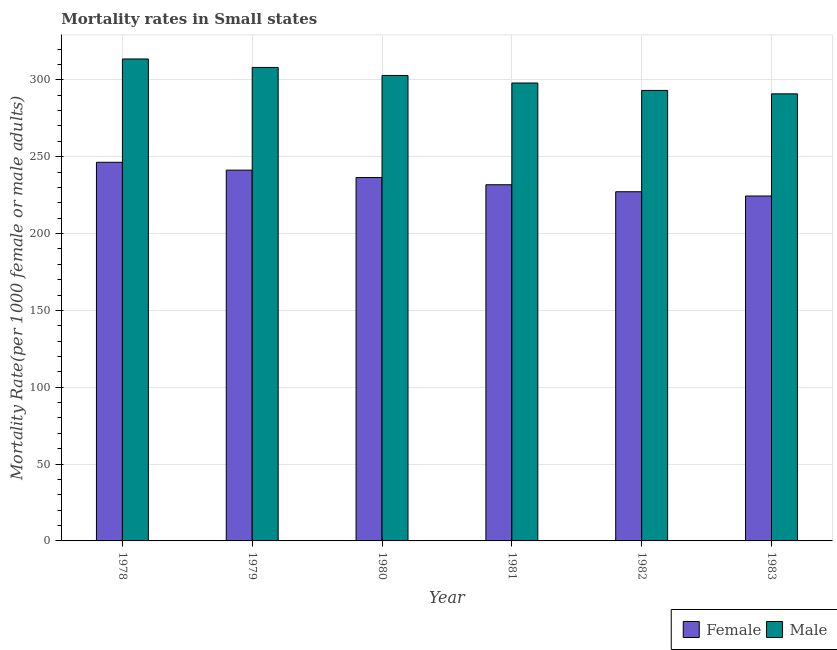How many different coloured bars are there?
Give a very brief answer. 2. How many groups of bars are there?
Your response must be concise. 6. Are the number of bars on each tick of the X-axis equal?
Provide a succinct answer. Yes. How many bars are there on the 5th tick from the right?
Ensure brevity in your answer.  2. What is the male mortality rate in 1982?
Your answer should be very brief. 293.12. Across all years, what is the maximum female mortality rate?
Your answer should be compact. 246.35. Across all years, what is the minimum female mortality rate?
Give a very brief answer. 224.41. In which year was the male mortality rate maximum?
Keep it short and to the point. 1978. What is the total female mortality rate in the graph?
Ensure brevity in your answer.  1407.39. What is the difference between the female mortality rate in 1978 and that in 1981?
Provide a short and direct response. 14.61. What is the difference between the male mortality rate in 1978 and the female mortality rate in 1983?
Ensure brevity in your answer.  22.68. What is the average male mortality rate per year?
Provide a short and direct response. 301.08. In the year 1981, what is the difference between the male mortality rate and female mortality rate?
Provide a succinct answer. 0. In how many years, is the male mortality rate greater than 150?
Your response must be concise. 6. What is the ratio of the female mortality rate in 1980 to that in 1983?
Keep it short and to the point. 1.05. Is the female mortality rate in 1978 less than that in 1981?
Offer a terse response. No. What is the difference between the highest and the second highest female mortality rate?
Make the answer very short. 5.1. What is the difference between the highest and the lowest female mortality rate?
Your response must be concise. 21.94. Is the sum of the male mortality rate in 1981 and 1983 greater than the maximum female mortality rate across all years?
Your response must be concise. Yes. Are all the bars in the graph horizontal?
Provide a short and direct response. No. What is the difference between two consecutive major ticks on the Y-axis?
Ensure brevity in your answer.  50. Are the values on the major ticks of Y-axis written in scientific E-notation?
Ensure brevity in your answer.  No. Where does the legend appear in the graph?
Offer a very short reply. Bottom right. How many legend labels are there?
Your answer should be very brief. 2. How are the legend labels stacked?
Make the answer very short. Horizontal. What is the title of the graph?
Keep it short and to the point. Mortality rates in Small states. Does "Money lenders" appear as one of the legend labels in the graph?
Your response must be concise. No. What is the label or title of the X-axis?
Provide a short and direct response. Year. What is the label or title of the Y-axis?
Provide a succinct answer. Mortality Rate(per 1000 female or male adults). What is the Mortality Rate(per 1000 female or male adults) in Female in 1978?
Ensure brevity in your answer.  246.35. What is the Mortality Rate(per 1000 female or male adults) of Male in 1978?
Offer a terse response. 313.58. What is the Mortality Rate(per 1000 female or male adults) of Female in 1979?
Give a very brief answer. 241.25. What is the Mortality Rate(per 1000 female or male adults) in Male in 1979?
Provide a short and direct response. 308.07. What is the Mortality Rate(per 1000 female or male adults) of Female in 1980?
Give a very brief answer. 236.45. What is the Mortality Rate(per 1000 female or male adults) in Male in 1980?
Give a very brief answer. 302.86. What is the Mortality Rate(per 1000 female or male adults) of Female in 1981?
Offer a terse response. 231.74. What is the Mortality Rate(per 1000 female or male adults) in Male in 1981?
Ensure brevity in your answer.  297.94. What is the Mortality Rate(per 1000 female or male adults) in Female in 1982?
Give a very brief answer. 227.19. What is the Mortality Rate(per 1000 female or male adults) in Male in 1982?
Keep it short and to the point. 293.12. What is the Mortality Rate(per 1000 female or male adults) in Female in 1983?
Make the answer very short. 224.41. What is the Mortality Rate(per 1000 female or male adults) in Male in 1983?
Ensure brevity in your answer.  290.89. Across all years, what is the maximum Mortality Rate(per 1000 female or male adults) of Female?
Provide a short and direct response. 246.35. Across all years, what is the maximum Mortality Rate(per 1000 female or male adults) in Male?
Your response must be concise. 313.58. Across all years, what is the minimum Mortality Rate(per 1000 female or male adults) of Female?
Your answer should be compact. 224.41. Across all years, what is the minimum Mortality Rate(per 1000 female or male adults) in Male?
Offer a terse response. 290.89. What is the total Mortality Rate(per 1000 female or male adults) in Female in the graph?
Your answer should be compact. 1407.39. What is the total Mortality Rate(per 1000 female or male adults) in Male in the graph?
Make the answer very short. 1806.46. What is the difference between the Mortality Rate(per 1000 female or male adults) in Female in 1978 and that in 1979?
Your answer should be very brief. 5.1. What is the difference between the Mortality Rate(per 1000 female or male adults) of Male in 1978 and that in 1979?
Provide a short and direct response. 5.51. What is the difference between the Mortality Rate(per 1000 female or male adults) of Female in 1978 and that in 1980?
Give a very brief answer. 9.9. What is the difference between the Mortality Rate(per 1000 female or male adults) in Male in 1978 and that in 1980?
Offer a very short reply. 10.72. What is the difference between the Mortality Rate(per 1000 female or male adults) of Female in 1978 and that in 1981?
Your answer should be compact. 14.61. What is the difference between the Mortality Rate(per 1000 female or male adults) in Male in 1978 and that in 1981?
Keep it short and to the point. 15.63. What is the difference between the Mortality Rate(per 1000 female or male adults) of Female in 1978 and that in 1982?
Provide a short and direct response. 19.16. What is the difference between the Mortality Rate(per 1000 female or male adults) in Male in 1978 and that in 1982?
Give a very brief answer. 20.46. What is the difference between the Mortality Rate(per 1000 female or male adults) in Female in 1978 and that in 1983?
Make the answer very short. 21.94. What is the difference between the Mortality Rate(per 1000 female or male adults) in Male in 1978 and that in 1983?
Offer a terse response. 22.68. What is the difference between the Mortality Rate(per 1000 female or male adults) in Female in 1979 and that in 1980?
Offer a very short reply. 4.8. What is the difference between the Mortality Rate(per 1000 female or male adults) in Male in 1979 and that in 1980?
Offer a terse response. 5.21. What is the difference between the Mortality Rate(per 1000 female or male adults) in Female in 1979 and that in 1981?
Make the answer very short. 9.51. What is the difference between the Mortality Rate(per 1000 female or male adults) of Male in 1979 and that in 1981?
Make the answer very short. 10.13. What is the difference between the Mortality Rate(per 1000 female or male adults) of Female in 1979 and that in 1982?
Your answer should be compact. 14.06. What is the difference between the Mortality Rate(per 1000 female or male adults) in Male in 1979 and that in 1982?
Your answer should be very brief. 14.95. What is the difference between the Mortality Rate(per 1000 female or male adults) of Female in 1979 and that in 1983?
Your answer should be compact. 16.84. What is the difference between the Mortality Rate(per 1000 female or male adults) in Male in 1979 and that in 1983?
Your answer should be compact. 17.18. What is the difference between the Mortality Rate(per 1000 female or male adults) in Female in 1980 and that in 1981?
Keep it short and to the point. 4.7. What is the difference between the Mortality Rate(per 1000 female or male adults) in Male in 1980 and that in 1981?
Make the answer very short. 4.92. What is the difference between the Mortality Rate(per 1000 female or male adults) of Female in 1980 and that in 1982?
Your answer should be very brief. 9.26. What is the difference between the Mortality Rate(per 1000 female or male adults) in Male in 1980 and that in 1982?
Ensure brevity in your answer.  9.74. What is the difference between the Mortality Rate(per 1000 female or male adults) of Female in 1980 and that in 1983?
Make the answer very short. 12.04. What is the difference between the Mortality Rate(per 1000 female or male adults) of Male in 1980 and that in 1983?
Keep it short and to the point. 11.97. What is the difference between the Mortality Rate(per 1000 female or male adults) in Female in 1981 and that in 1982?
Provide a succinct answer. 4.56. What is the difference between the Mortality Rate(per 1000 female or male adults) of Male in 1981 and that in 1982?
Make the answer very short. 4.83. What is the difference between the Mortality Rate(per 1000 female or male adults) in Female in 1981 and that in 1983?
Your response must be concise. 7.33. What is the difference between the Mortality Rate(per 1000 female or male adults) of Male in 1981 and that in 1983?
Your response must be concise. 7.05. What is the difference between the Mortality Rate(per 1000 female or male adults) in Female in 1982 and that in 1983?
Offer a very short reply. 2.78. What is the difference between the Mortality Rate(per 1000 female or male adults) in Male in 1982 and that in 1983?
Your answer should be compact. 2.22. What is the difference between the Mortality Rate(per 1000 female or male adults) in Female in 1978 and the Mortality Rate(per 1000 female or male adults) in Male in 1979?
Your response must be concise. -61.72. What is the difference between the Mortality Rate(per 1000 female or male adults) in Female in 1978 and the Mortality Rate(per 1000 female or male adults) in Male in 1980?
Your response must be concise. -56.51. What is the difference between the Mortality Rate(per 1000 female or male adults) of Female in 1978 and the Mortality Rate(per 1000 female or male adults) of Male in 1981?
Your answer should be compact. -51.59. What is the difference between the Mortality Rate(per 1000 female or male adults) in Female in 1978 and the Mortality Rate(per 1000 female or male adults) in Male in 1982?
Keep it short and to the point. -46.77. What is the difference between the Mortality Rate(per 1000 female or male adults) in Female in 1978 and the Mortality Rate(per 1000 female or male adults) in Male in 1983?
Provide a short and direct response. -44.54. What is the difference between the Mortality Rate(per 1000 female or male adults) in Female in 1979 and the Mortality Rate(per 1000 female or male adults) in Male in 1980?
Keep it short and to the point. -61.61. What is the difference between the Mortality Rate(per 1000 female or male adults) of Female in 1979 and the Mortality Rate(per 1000 female or male adults) of Male in 1981?
Give a very brief answer. -56.69. What is the difference between the Mortality Rate(per 1000 female or male adults) in Female in 1979 and the Mortality Rate(per 1000 female or male adults) in Male in 1982?
Your response must be concise. -51.87. What is the difference between the Mortality Rate(per 1000 female or male adults) of Female in 1979 and the Mortality Rate(per 1000 female or male adults) of Male in 1983?
Provide a succinct answer. -49.64. What is the difference between the Mortality Rate(per 1000 female or male adults) of Female in 1980 and the Mortality Rate(per 1000 female or male adults) of Male in 1981?
Your answer should be compact. -61.5. What is the difference between the Mortality Rate(per 1000 female or male adults) of Female in 1980 and the Mortality Rate(per 1000 female or male adults) of Male in 1982?
Make the answer very short. -56.67. What is the difference between the Mortality Rate(per 1000 female or male adults) of Female in 1980 and the Mortality Rate(per 1000 female or male adults) of Male in 1983?
Make the answer very short. -54.45. What is the difference between the Mortality Rate(per 1000 female or male adults) in Female in 1981 and the Mortality Rate(per 1000 female or male adults) in Male in 1982?
Your answer should be compact. -61.37. What is the difference between the Mortality Rate(per 1000 female or male adults) of Female in 1981 and the Mortality Rate(per 1000 female or male adults) of Male in 1983?
Make the answer very short. -59.15. What is the difference between the Mortality Rate(per 1000 female or male adults) in Female in 1982 and the Mortality Rate(per 1000 female or male adults) in Male in 1983?
Your response must be concise. -63.71. What is the average Mortality Rate(per 1000 female or male adults) of Female per year?
Offer a very short reply. 234.57. What is the average Mortality Rate(per 1000 female or male adults) of Male per year?
Provide a short and direct response. 301.08. In the year 1978, what is the difference between the Mortality Rate(per 1000 female or male adults) in Female and Mortality Rate(per 1000 female or male adults) in Male?
Give a very brief answer. -67.23. In the year 1979, what is the difference between the Mortality Rate(per 1000 female or male adults) of Female and Mortality Rate(per 1000 female or male adults) of Male?
Ensure brevity in your answer.  -66.82. In the year 1980, what is the difference between the Mortality Rate(per 1000 female or male adults) of Female and Mortality Rate(per 1000 female or male adults) of Male?
Your response must be concise. -66.41. In the year 1981, what is the difference between the Mortality Rate(per 1000 female or male adults) of Female and Mortality Rate(per 1000 female or male adults) of Male?
Ensure brevity in your answer.  -66.2. In the year 1982, what is the difference between the Mortality Rate(per 1000 female or male adults) of Female and Mortality Rate(per 1000 female or male adults) of Male?
Your answer should be very brief. -65.93. In the year 1983, what is the difference between the Mortality Rate(per 1000 female or male adults) in Female and Mortality Rate(per 1000 female or male adults) in Male?
Provide a short and direct response. -66.48. What is the ratio of the Mortality Rate(per 1000 female or male adults) of Female in 1978 to that in 1979?
Provide a succinct answer. 1.02. What is the ratio of the Mortality Rate(per 1000 female or male adults) in Male in 1978 to that in 1979?
Ensure brevity in your answer.  1.02. What is the ratio of the Mortality Rate(per 1000 female or male adults) in Female in 1978 to that in 1980?
Make the answer very short. 1.04. What is the ratio of the Mortality Rate(per 1000 female or male adults) of Male in 1978 to that in 1980?
Ensure brevity in your answer.  1.04. What is the ratio of the Mortality Rate(per 1000 female or male adults) in Female in 1978 to that in 1981?
Give a very brief answer. 1.06. What is the ratio of the Mortality Rate(per 1000 female or male adults) of Male in 1978 to that in 1981?
Give a very brief answer. 1.05. What is the ratio of the Mortality Rate(per 1000 female or male adults) of Female in 1978 to that in 1982?
Offer a terse response. 1.08. What is the ratio of the Mortality Rate(per 1000 female or male adults) in Male in 1978 to that in 1982?
Provide a succinct answer. 1.07. What is the ratio of the Mortality Rate(per 1000 female or male adults) of Female in 1978 to that in 1983?
Offer a very short reply. 1.1. What is the ratio of the Mortality Rate(per 1000 female or male adults) in Male in 1978 to that in 1983?
Your response must be concise. 1.08. What is the ratio of the Mortality Rate(per 1000 female or male adults) in Female in 1979 to that in 1980?
Provide a succinct answer. 1.02. What is the ratio of the Mortality Rate(per 1000 female or male adults) in Male in 1979 to that in 1980?
Your answer should be compact. 1.02. What is the ratio of the Mortality Rate(per 1000 female or male adults) in Female in 1979 to that in 1981?
Your answer should be very brief. 1.04. What is the ratio of the Mortality Rate(per 1000 female or male adults) of Male in 1979 to that in 1981?
Provide a short and direct response. 1.03. What is the ratio of the Mortality Rate(per 1000 female or male adults) in Female in 1979 to that in 1982?
Your response must be concise. 1.06. What is the ratio of the Mortality Rate(per 1000 female or male adults) in Male in 1979 to that in 1982?
Ensure brevity in your answer.  1.05. What is the ratio of the Mortality Rate(per 1000 female or male adults) of Female in 1979 to that in 1983?
Your answer should be very brief. 1.07. What is the ratio of the Mortality Rate(per 1000 female or male adults) of Male in 1979 to that in 1983?
Keep it short and to the point. 1.06. What is the ratio of the Mortality Rate(per 1000 female or male adults) of Female in 1980 to that in 1981?
Offer a terse response. 1.02. What is the ratio of the Mortality Rate(per 1000 female or male adults) of Male in 1980 to that in 1981?
Ensure brevity in your answer.  1.02. What is the ratio of the Mortality Rate(per 1000 female or male adults) of Female in 1980 to that in 1982?
Offer a very short reply. 1.04. What is the ratio of the Mortality Rate(per 1000 female or male adults) in Male in 1980 to that in 1982?
Give a very brief answer. 1.03. What is the ratio of the Mortality Rate(per 1000 female or male adults) of Female in 1980 to that in 1983?
Your response must be concise. 1.05. What is the ratio of the Mortality Rate(per 1000 female or male adults) in Male in 1980 to that in 1983?
Your answer should be very brief. 1.04. What is the ratio of the Mortality Rate(per 1000 female or male adults) of Female in 1981 to that in 1982?
Offer a terse response. 1.02. What is the ratio of the Mortality Rate(per 1000 female or male adults) of Male in 1981 to that in 1982?
Your response must be concise. 1.02. What is the ratio of the Mortality Rate(per 1000 female or male adults) in Female in 1981 to that in 1983?
Ensure brevity in your answer.  1.03. What is the ratio of the Mortality Rate(per 1000 female or male adults) of Male in 1981 to that in 1983?
Make the answer very short. 1.02. What is the ratio of the Mortality Rate(per 1000 female or male adults) of Female in 1982 to that in 1983?
Your answer should be compact. 1.01. What is the ratio of the Mortality Rate(per 1000 female or male adults) of Male in 1982 to that in 1983?
Your answer should be compact. 1.01. What is the difference between the highest and the second highest Mortality Rate(per 1000 female or male adults) in Female?
Your answer should be very brief. 5.1. What is the difference between the highest and the second highest Mortality Rate(per 1000 female or male adults) in Male?
Offer a terse response. 5.51. What is the difference between the highest and the lowest Mortality Rate(per 1000 female or male adults) in Female?
Your answer should be compact. 21.94. What is the difference between the highest and the lowest Mortality Rate(per 1000 female or male adults) of Male?
Keep it short and to the point. 22.68. 